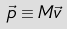<formula> <loc_0><loc_0><loc_500><loc_500>\vec { p } \equiv M \vec { v }</formula> 